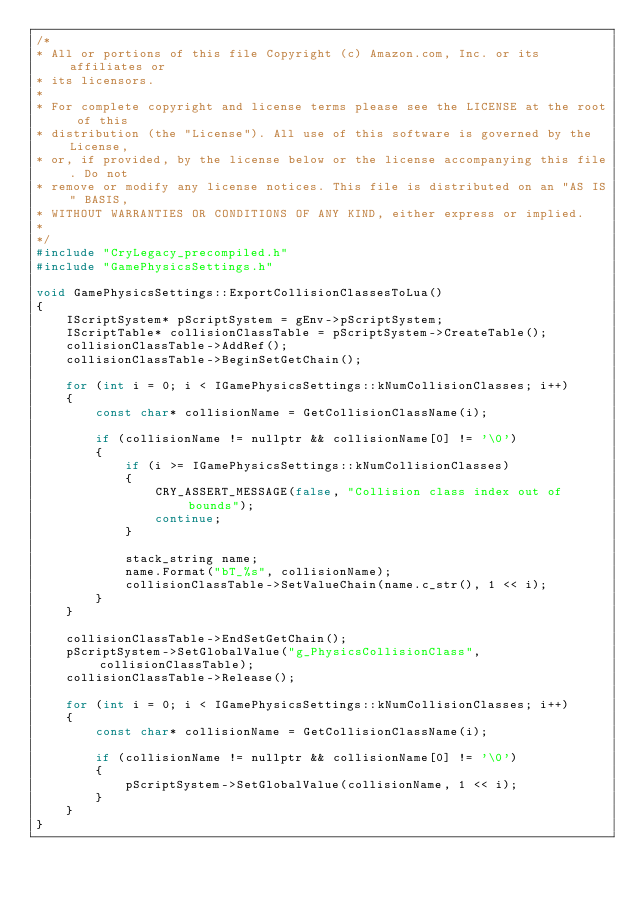Convert code to text. <code><loc_0><loc_0><loc_500><loc_500><_C++_>/*
* All or portions of this file Copyright (c) Amazon.com, Inc. or its affiliates or
* its licensors.
*
* For complete copyright and license terms please see the LICENSE at the root of this
* distribution (the "License"). All use of this software is governed by the License,
* or, if provided, by the license below or the license accompanying this file. Do not
* remove or modify any license notices. This file is distributed on an "AS IS" BASIS,
* WITHOUT WARRANTIES OR CONDITIONS OF ANY KIND, either express or implied.
*
*/
#include "CryLegacy_precompiled.h"
#include "GamePhysicsSettings.h"

void GamePhysicsSettings::ExportCollisionClassesToLua()
{
    IScriptSystem* pScriptSystem = gEnv->pScriptSystem;
    IScriptTable* collisionClassTable = pScriptSystem->CreateTable();
    collisionClassTable->AddRef();
    collisionClassTable->BeginSetGetChain();

    for (int i = 0; i < IGamePhysicsSettings::kNumCollisionClasses; i++)
    {
        const char* collisionName = GetCollisionClassName(i);

        if (collisionName != nullptr && collisionName[0] != '\0')
        {
            if (i >= IGamePhysicsSettings::kNumCollisionClasses)
            {
                CRY_ASSERT_MESSAGE(false, "Collision class index out of bounds");
                continue;
            }

            stack_string name;
            name.Format("bT_%s", collisionName);
            collisionClassTable->SetValueChain(name.c_str(), 1 << i);
        }
    }

    collisionClassTable->EndSetGetChain();
    pScriptSystem->SetGlobalValue("g_PhysicsCollisionClass", collisionClassTable);
    collisionClassTable->Release();

    for (int i = 0; i < IGamePhysicsSettings::kNumCollisionClasses; i++)
    {
        const char* collisionName = GetCollisionClassName(i);

        if (collisionName != nullptr && collisionName[0] != '\0')
        {
            pScriptSystem->SetGlobalValue(collisionName, 1 << i);
        }
    }
}
</code> 